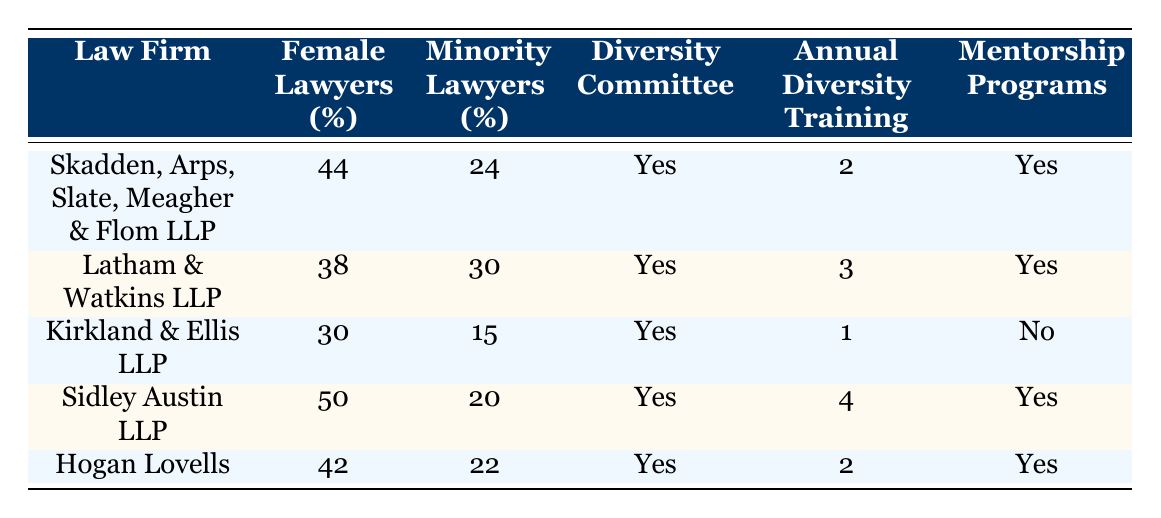What is the percentage of female lawyers at Sidley Austin LLP? The table shows that Sidley Austin LLP has 50% of its lawyers as female.
Answer: 50 Which law firm has the highest percentage of minority lawyers? By comparing the percentages in the table, Latham & Watkins LLP has the highest percentage of minority lawyers at 30%.
Answer: 30 Do all law firms have a diversity committee established? Checking the table, all listed law firms have a diversity committee established, indicated by "Yes" in the relevant column.
Answer: Yes What is the average percentage of female lawyers across the five firms? To find the average, add the percentages: (44 + 38 + 30 + 50 + 42) = 204. Then divide by the number of firms (5): 204 / 5 = 40.8.
Answer: 40.8 Which law firm has the fewest annual diversity training programs? Comparing the annual diversity training columns, Kirkland & Ellis LLP has the fewest with only 1 program.
Answer: 1 Is there a law firm that has mentorship programs implemented but fewer diversity training programs than Kirkland & Ellis LLP? From the table, both Skadden, Arps, Slate, Meagher & Flom LLP and Hogan Lovells have implemented mentorship programs and have 2 diversity training programs, which is more than Kirkland & Ellis LLP's 1. No law firm meets these criteria.
Answer: No 